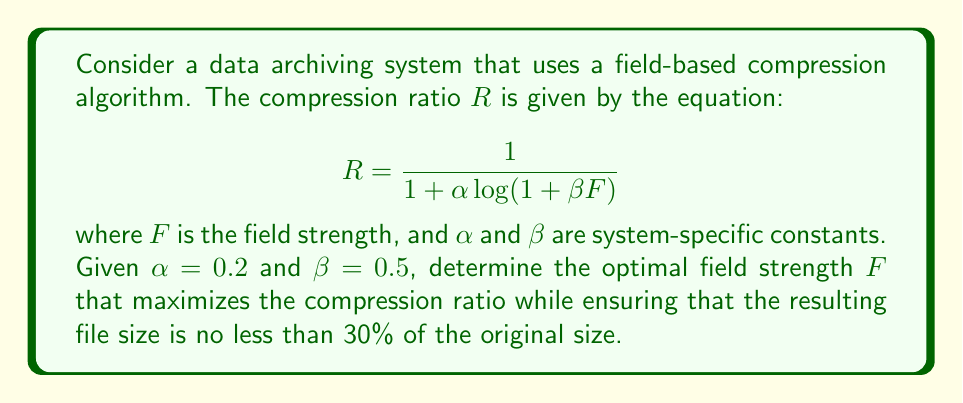Show me your answer to this math problem. To solve this problem, we'll follow these steps:

1) First, we need to understand the constraints. We want to maximize $R$, but ensure that the compressed file is at least 30% of the original size. This means:

   $R \leq \frac{1}{0.3} \approx 3.33$

2) Now, let's express this constraint in terms of $F$:

   $$\frac{1}{1 + 0.2 \log(1 + 0.5F)} \leq 3.33$$

3) Solving this inequality:

   $$1 + 0.2 \log(1 + 0.5F) \geq 0.3$$
   $$0.2 \log(1 + 0.5F) \geq -0.7$$
   $$\log(1 + 0.5F) \geq -3.5$$
   $$1 + 0.5F \geq e^{-3.5}$$
   $$0.5F \geq e^{-3.5} - 1$$
   $$F \geq 2(e^{-3.5} - 1) \approx -0.0599$$

4) Since $F$ represents field strength, it must be non-negative. So our constraint is effectively $F \geq 0$.

5) To find the optimal $F$, we need to maximize $R$. This is equivalent to minimizing $1/R$:

   $$\frac{1}{R} = 1 + 0.2 \log(1 + 0.5F)$$

6) To find the minimum, we differentiate with respect to $F$ and set to zero:

   $$\frac{d}{dF}(\frac{1}{R}) = \frac{0.2 \cdot 0.5}{1 + 0.5F} = 0$$

7) This equation is only satisfied when $F$ approaches infinity. However, as $F$ increases, $R$ approaches its maximum value of 1.

8) Therefore, there is no finite optimal $F$. The compression ratio improves asymptotically as $F$ increases.

9) In practice, we would choose the highest feasible $F$ value based on system limitations and diminishing returns.
Answer: No finite optimal $F$; choose highest feasible value. 